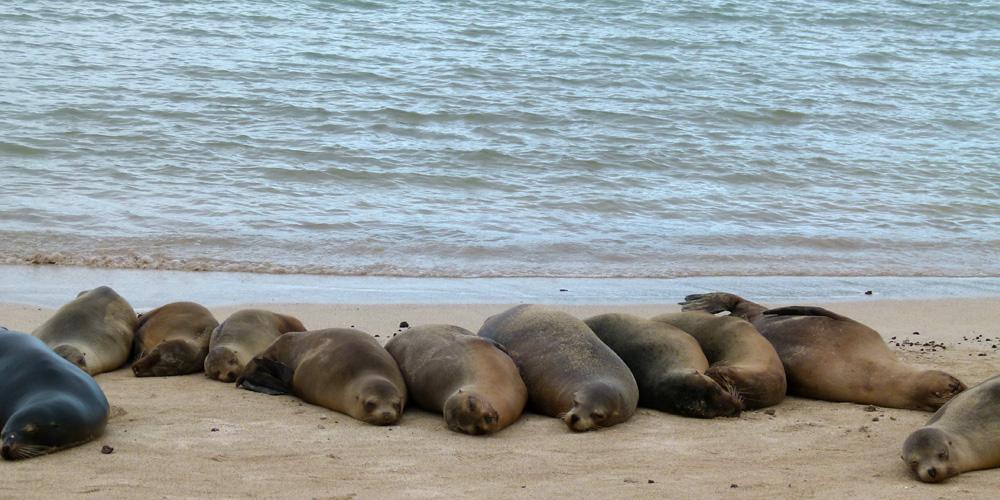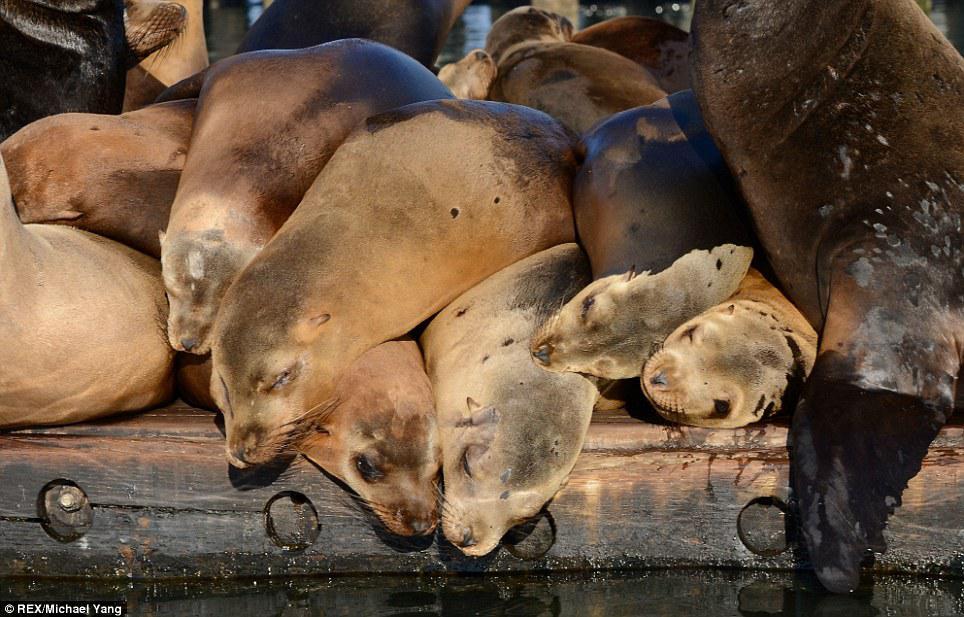The first image is the image on the left, the second image is the image on the right. Assess this claim about the two images: "One image has no more than three seals laying on rocks.". Correct or not? Answer yes or no. No. The first image is the image on the left, the second image is the image on the right. Evaluate the accuracy of this statement regarding the images: "In at least one image there are seals laying on a wooden dock". Is it true? Answer yes or no. Yes. 